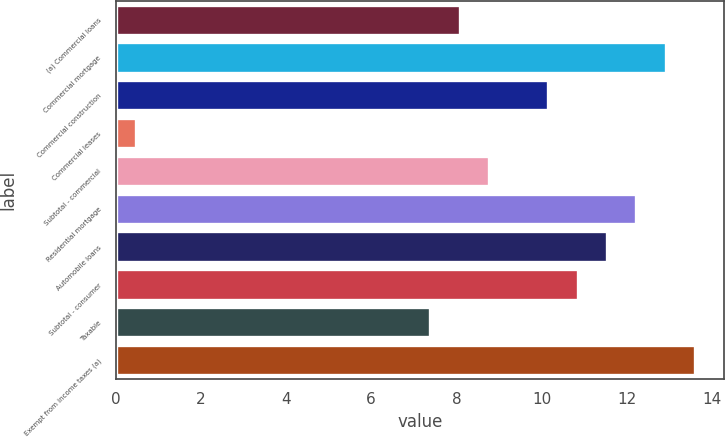Convert chart. <chart><loc_0><loc_0><loc_500><loc_500><bar_chart><fcel>(a) Commercial loans<fcel>Commercial mortgage<fcel>Commercial construction<fcel>Commercial leases<fcel>Subtotal - commercial<fcel>Residential mortgage<fcel>Automobile loans<fcel>Subtotal - consumer<fcel>Taxable<fcel>Exempt from income taxes (a)<nl><fcel>8.08<fcel>12.91<fcel>10.15<fcel>0.49<fcel>8.77<fcel>12.22<fcel>11.53<fcel>10.84<fcel>7.39<fcel>13.6<nl></chart> 